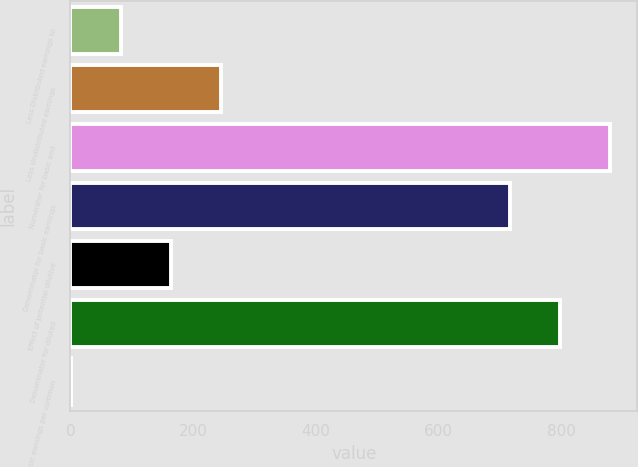Convert chart. <chart><loc_0><loc_0><loc_500><loc_500><bar_chart><fcel>Less Distributed earnings to<fcel>Less Undistributed earnings<fcel>Numerator for basic and<fcel>Denominator for basic earnings<fcel>Effect of potential dilutive<fcel>Denominator for diluted<fcel>Basic earnings per common<nl><fcel>82.73<fcel>245.91<fcel>879.18<fcel>716<fcel>164.32<fcel>797.59<fcel>1.14<nl></chart> 